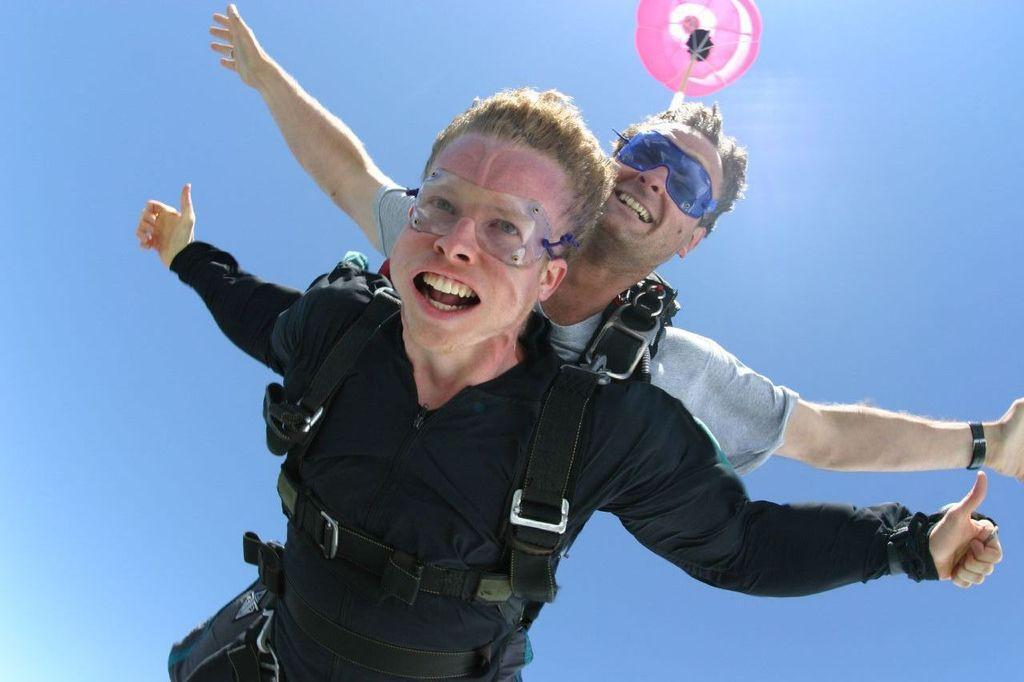How many people are in the image? There are two men in the image. What are the men wearing on their faces? The men are wearing spectacles. What is the men's current situation in the image? The men are in the air and using parachutes. What type of pie can be seen in the hands of the men in the image? There is no pie present in the image; the men are using parachutes while in the air. 